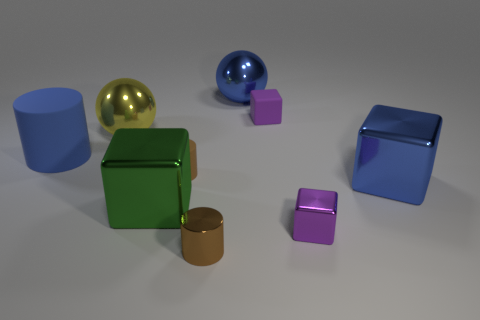How many rubber objects are either large blue balls or brown cylinders?
Provide a short and direct response. 1. What number of large blue metal spheres are behind the big ball that is left of the large green shiny thing?
Ensure brevity in your answer.  1. What number of other yellow things are made of the same material as the big yellow thing?
Your response must be concise. 0. What number of small things are either matte cylinders or blue rubber cylinders?
Offer a very short reply. 1. The blue thing that is left of the small shiny cube and on the right side of the yellow ball has what shape?
Offer a terse response. Sphere. Do the blue cylinder and the blue ball have the same material?
Offer a very short reply. No. There is a block that is the same size as the green metallic thing; what color is it?
Ensure brevity in your answer.  Blue. There is a object that is to the right of the large blue shiny sphere and behind the large rubber cylinder; what color is it?
Your answer should be very brief. Purple. There is a thing that is the same color as the tiny metal cube; what is its size?
Offer a very short reply. Small. There is a metallic thing that is the same color as the rubber block; what is its shape?
Your answer should be compact. Cube. 